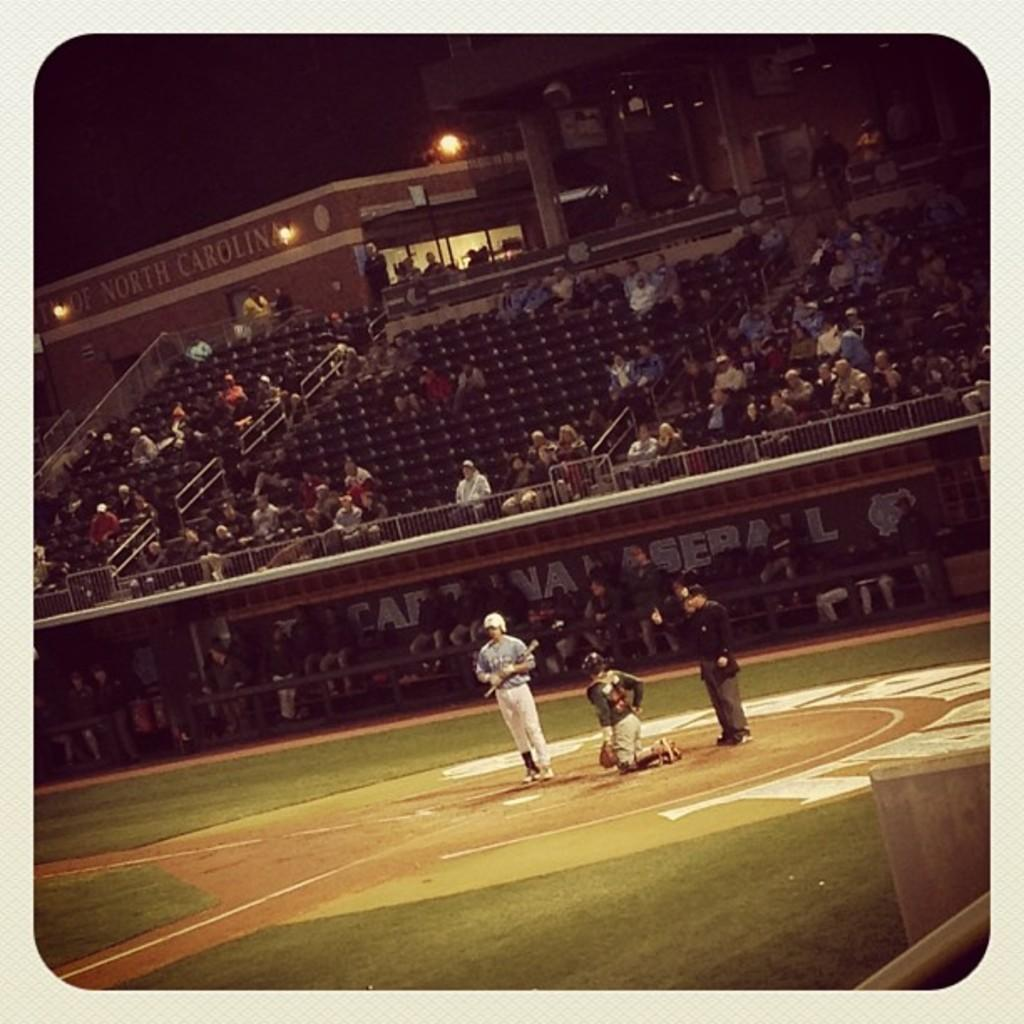<image>
Create a compact narrative representing the image presented. A baseball game is being played in North Carolina. 